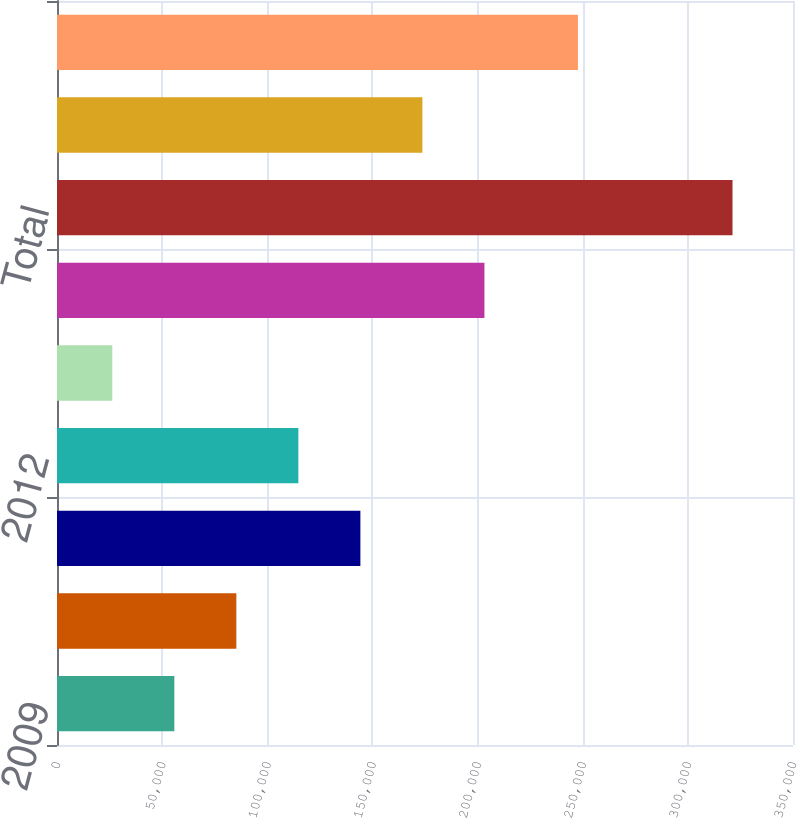Convert chart to OTSL. <chart><loc_0><loc_0><loc_500><loc_500><bar_chart><fcel>2009<fcel>2010<fcel>2011<fcel>2012<fcel>2013<fcel>Years thereafter<fcel>Total<fcel>Less Amount representing<fcel>Present value of net minimum<nl><fcel>55794.6<fcel>85288.2<fcel>144275<fcel>114782<fcel>26301<fcel>203263<fcel>321237<fcel>173769<fcel>247725<nl></chart> 